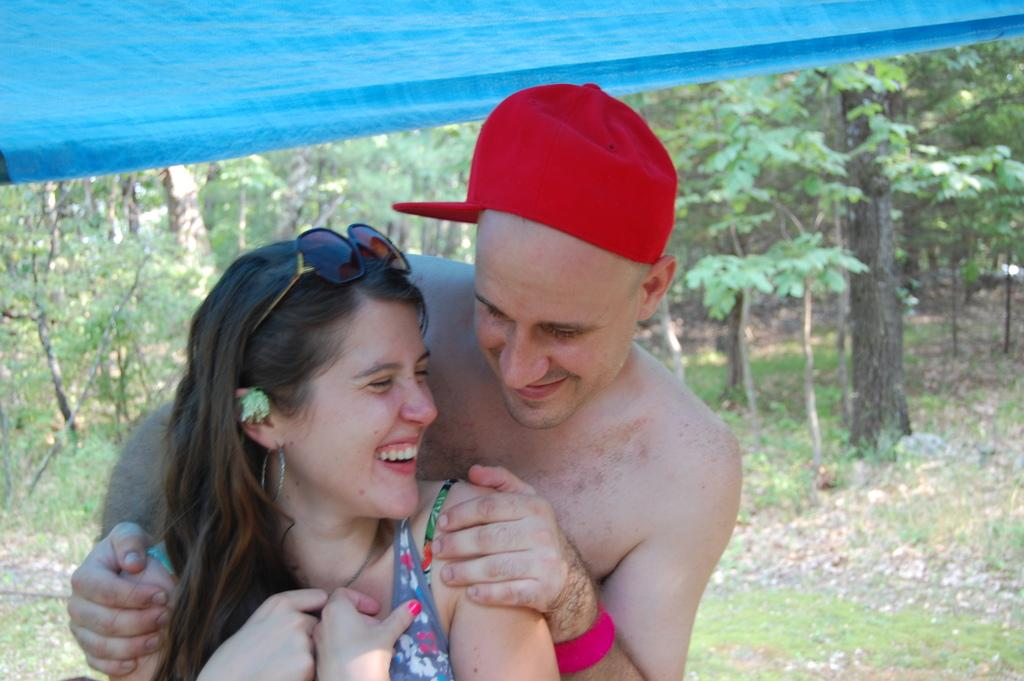Who is present in the image? There is a man and a woman in the image. What are the expressions on their faces? Both the man and the woman are smiling. What can be seen in the background of the image? There are trees in the background of the image. What type of cloth is being used to sing the song in the image? There is no cloth or song present in the image; it features a man and a woman smiling. 